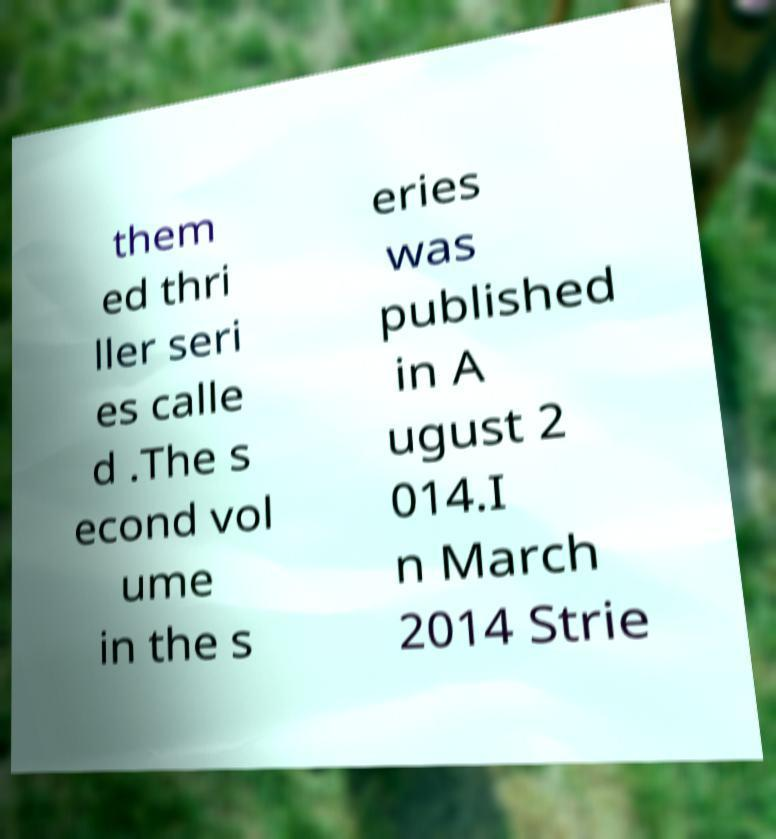For documentation purposes, I need the text within this image transcribed. Could you provide that? them ed thri ller seri es calle d .The s econd vol ume in the s eries was published in A ugust 2 014.I n March 2014 Strie 